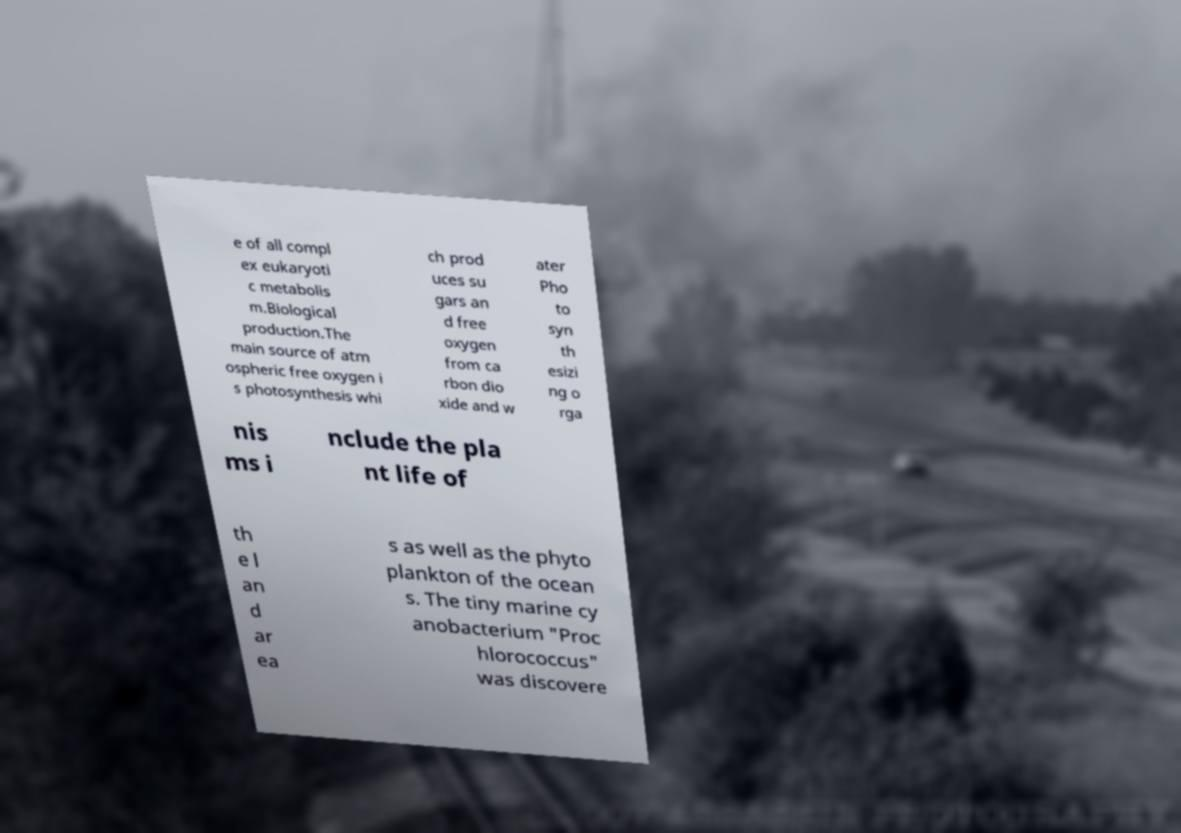I need the written content from this picture converted into text. Can you do that? e of all compl ex eukaryoti c metabolis m.Biological production.The main source of atm ospheric free oxygen i s photosynthesis whi ch prod uces su gars an d free oxygen from ca rbon dio xide and w ater Pho to syn th esizi ng o rga nis ms i nclude the pla nt life of th e l an d ar ea s as well as the phyto plankton of the ocean s. The tiny marine cy anobacterium "Proc hlorococcus" was discovere 